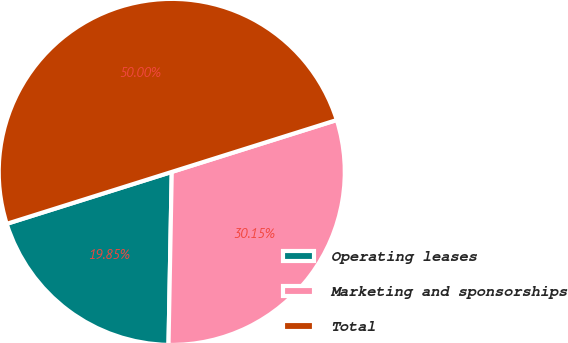<chart> <loc_0><loc_0><loc_500><loc_500><pie_chart><fcel>Operating leases<fcel>Marketing and sponsorships<fcel>Total<nl><fcel>19.85%<fcel>30.15%<fcel>50.0%<nl></chart> 